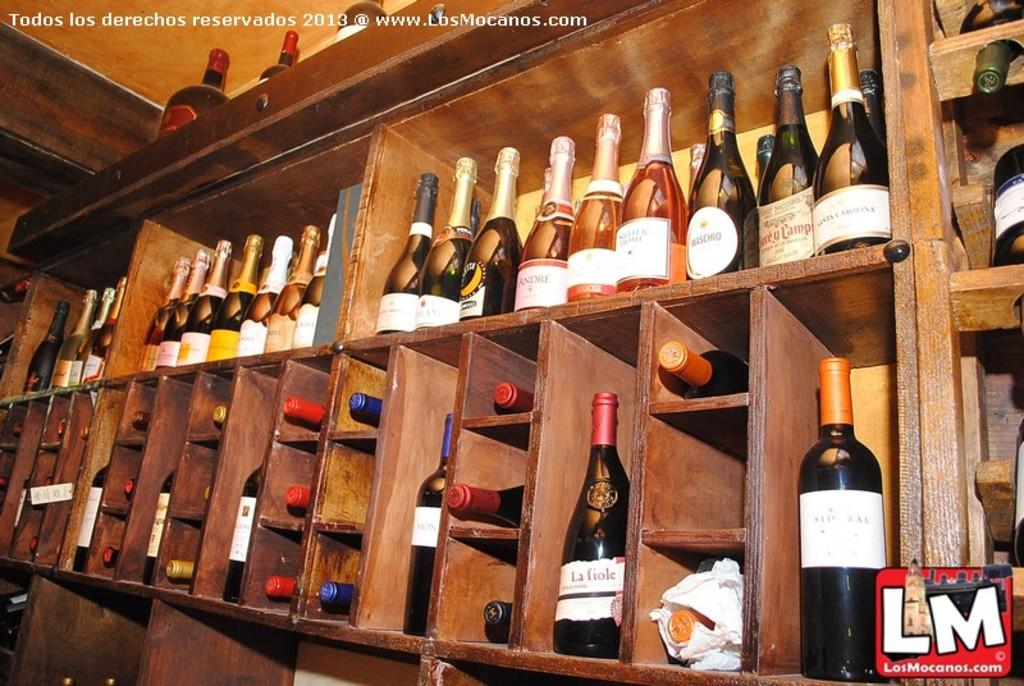What type of bottles are visible in the image? There are wine bottles in the image. Where are the wine bottles placed? The wine bottles are kept on wooden shelves. What type of cork is used to seal the wine bottles in the image? There is no information about the cork used to seal the wine bottles in the image. --- 